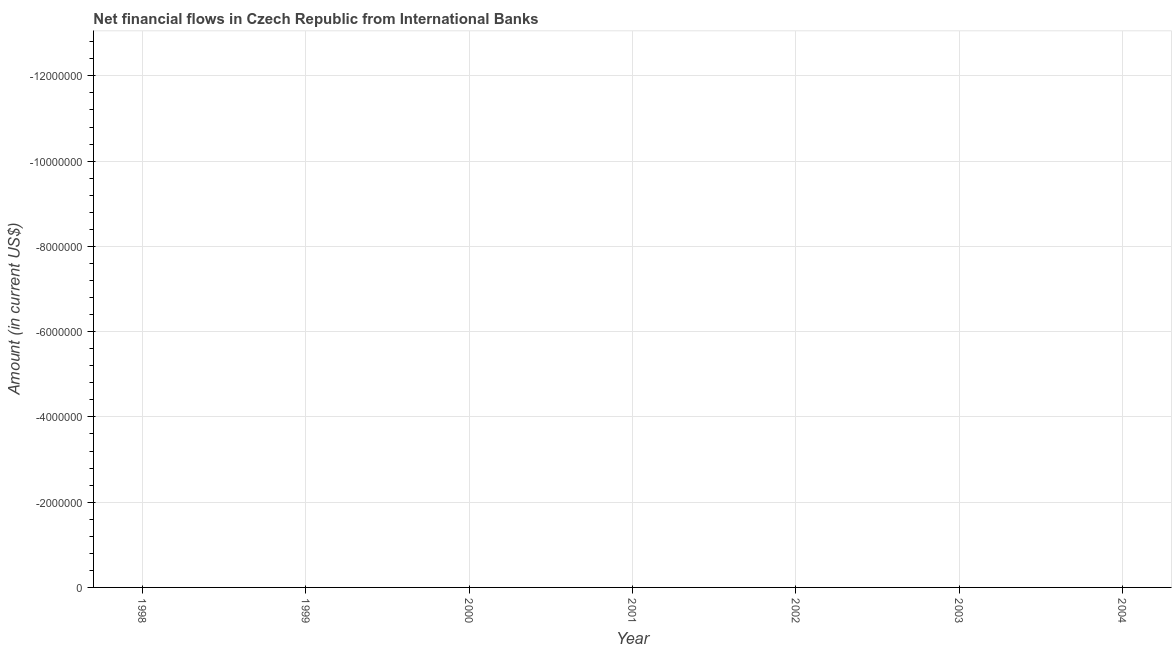What is the net financial flows from ibrd in 2004?
Your answer should be compact. 0. Does the net financial flows from ibrd monotonically increase over the years?
Provide a short and direct response. No. How many dotlines are there?
Your answer should be compact. 0. What is the difference between two consecutive major ticks on the Y-axis?
Provide a short and direct response. 2.00e+06. Does the graph contain any zero values?
Provide a succinct answer. Yes. Does the graph contain grids?
Ensure brevity in your answer.  Yes. What is the title of the graph?
Give a very brief answer. Net financial flows in Czech Republic from International Banks. What is the label or title of the X-axis?
Your answer should be very brief. Year. What is the label or title of the Y-axis?
Your answer should be very brief. Amount (in current US$). What is the Amount (in current US$) in 1999?
Provide a short and direct response. 0. What is the Amount (in current US$) in 2000?
Keep it short and to the point. 0. What is the Amount (in current US$) in 2001?
Give a very brief answer. 0. What is the Amount (in current US$) in 2002?
Offer a very short reply. 0. What is the Amount (in current US$) in 2003?
Offer a very short reply. 0. 